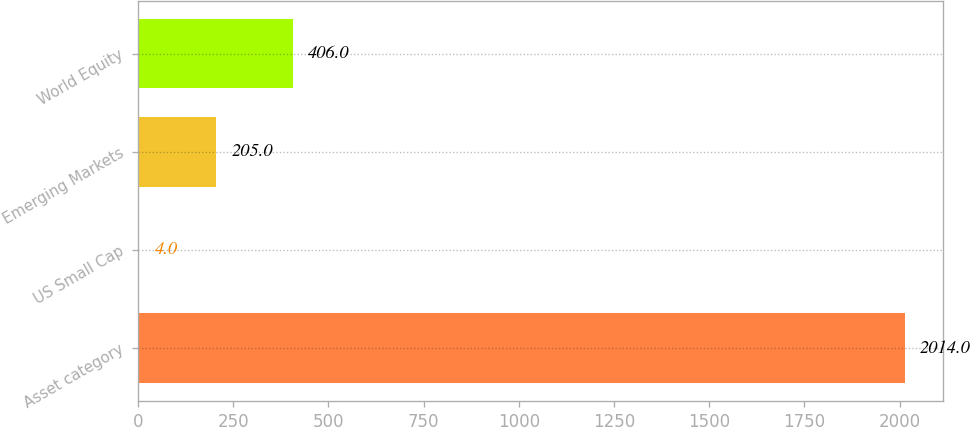<chart> <loc_0><loc_0><loc_500><loc_500><bar_chart><fcel>Asset category<fcel>US Small Cap<fcel>Emerging Markets<fcel>World Equity<nl><fcel>2014<fcel>4<fcel>205<fcel>406<nl></chart> 